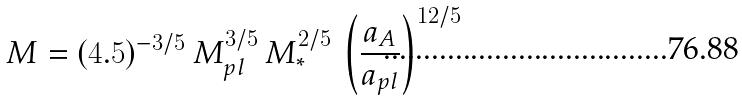<formula> <loc_0><loc_0><loc_500><loc_500>M = ( 4 . 5 ) ^ { - 3 / 5 } \, M ^ { 3 / 5 } _ { p l } \, M ^ { 2 / 5 } _ { * } \, \left ( \frac { a _ { A } } { a _ { p l } } \right ) ^ { 1 2 / 5 }</formula> 